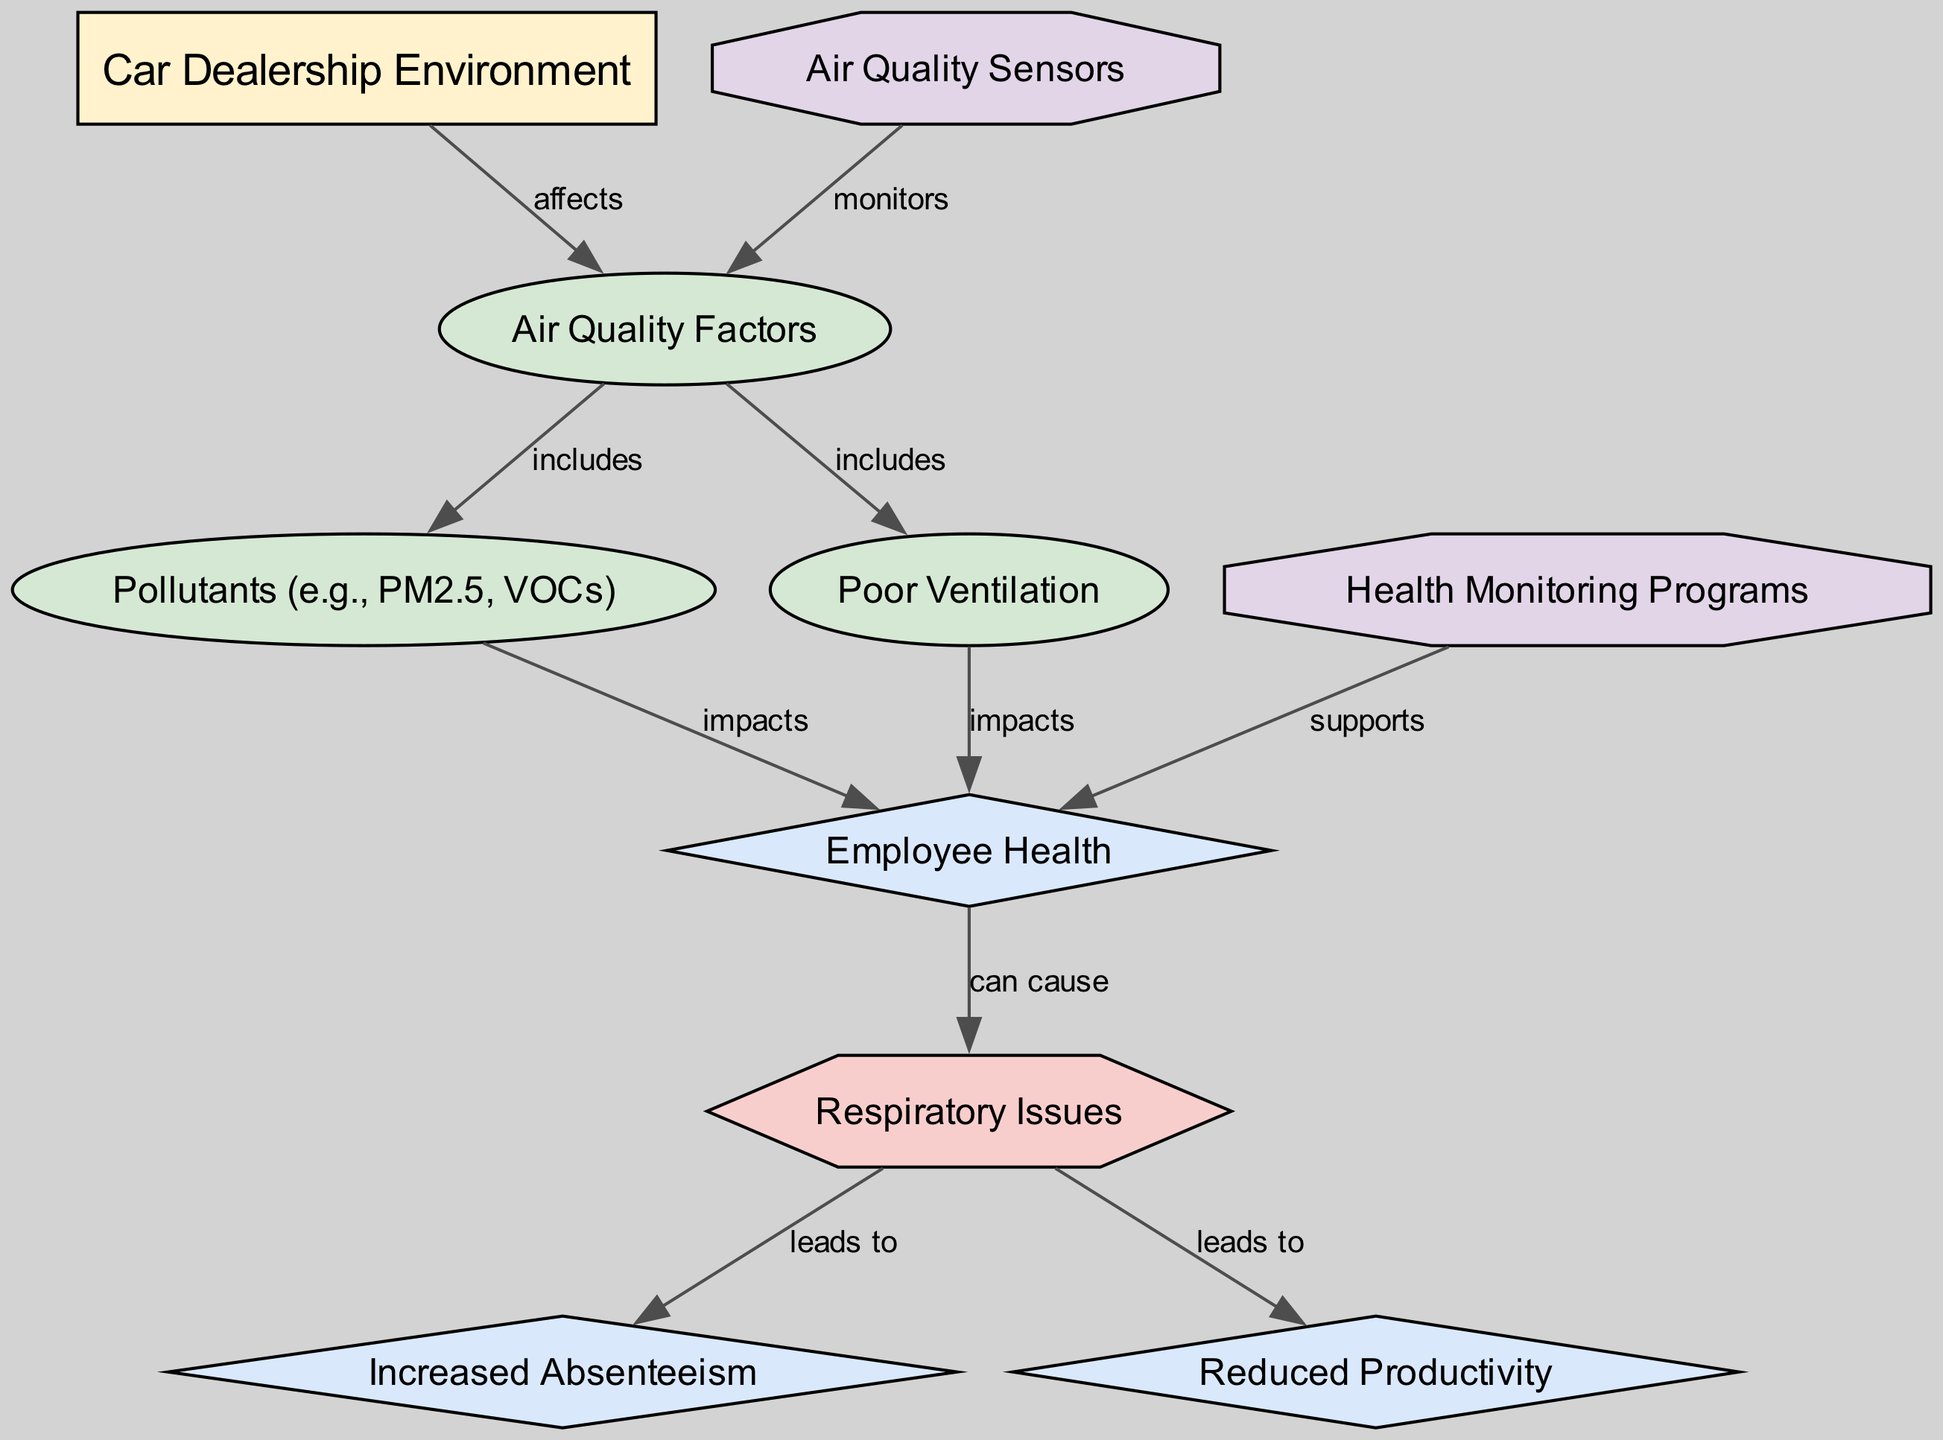What are the main factors affecting air quality in the car dealership environment? The diagram specifies two main factors under the "Air Quality Factors" node that affect air quality: "Pollutants (e.g., PM2.5, VOCs)" and "Poor Ventilation."
Answer: Pollutants (e.g., PM2.5, VOCs), Poor Ventilation What does poor ventilation impact? In the diagram, there is a direct connection showing that "Poor Ventilation" impacts "Employee Health."
Answer: Employee Health How many outcomes are identified in the diagram? There are three outcomes listed that can result from the discussed conditions or factors: "Employee Health," "Increased Absenteeism," and "Reduced Productivity."
Answer: Three Which intervention supports employee health? The diagram clearly indicates that "Health Monitoring Programs" is the intervention that supports "Employee Health."
Answer: Health Monitoring Programs What condition can arise from employee health issues? According to the diagram, the condition that arises from issues in employee health is "Respiratory Issues."
Answer: Respiratory Issues How do air quality factors influence respiratory issues? The diagram shows two pathways where air quality factors ("Pollutants" and "Poor Ventilation") both impact "Employee Health," which can subsequently lead to "Respiratory Issues," establishing a causal relationship.
Answer: They impact employee health, which can lead to respiratory issues Which air quality factor is mentioned as including emissions? The specific air quality factor that includes emissions, as labeled in the diagram, is "Pollutants (e.g., PM2.5, VOCs)."
Answer: Pollutants (e.g., PM2.5, VOCs) How are air quality sensors related to air quality factors? The edge labeled "monitors" connects "Air Quality Sensors" to "Air Quality Factors," indicating that air quality sensors monitor these factors in the dealership environment.
Answer: Monitors What outcomes are associated with respiratory issues? The diagram demonstrates that respiratory issues can lead to both "Increased Absenteeism" and "Reduced Productivity," signifying negative impacts on overall performance.
Answer: Increased Absenteeism, Reduced Productivity 